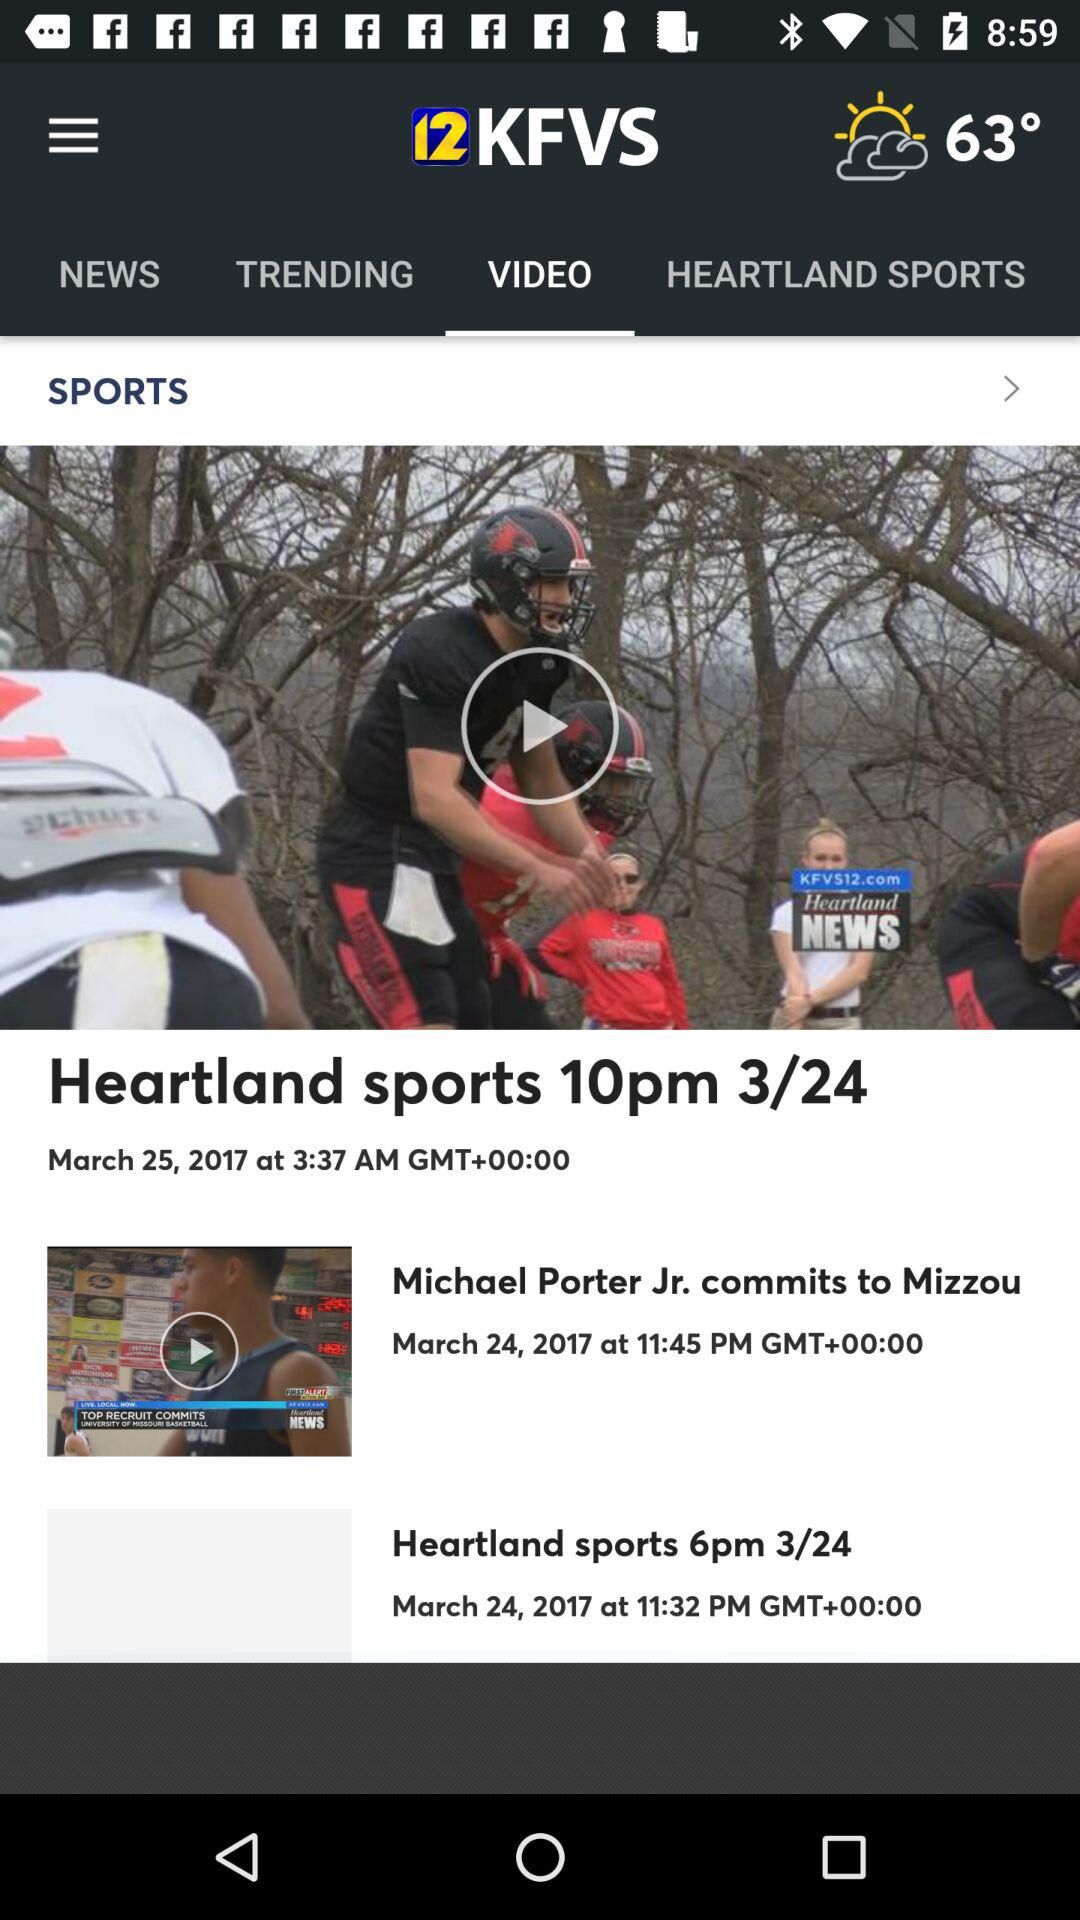What is the selected tab? The selected tab is "VIDEO". 